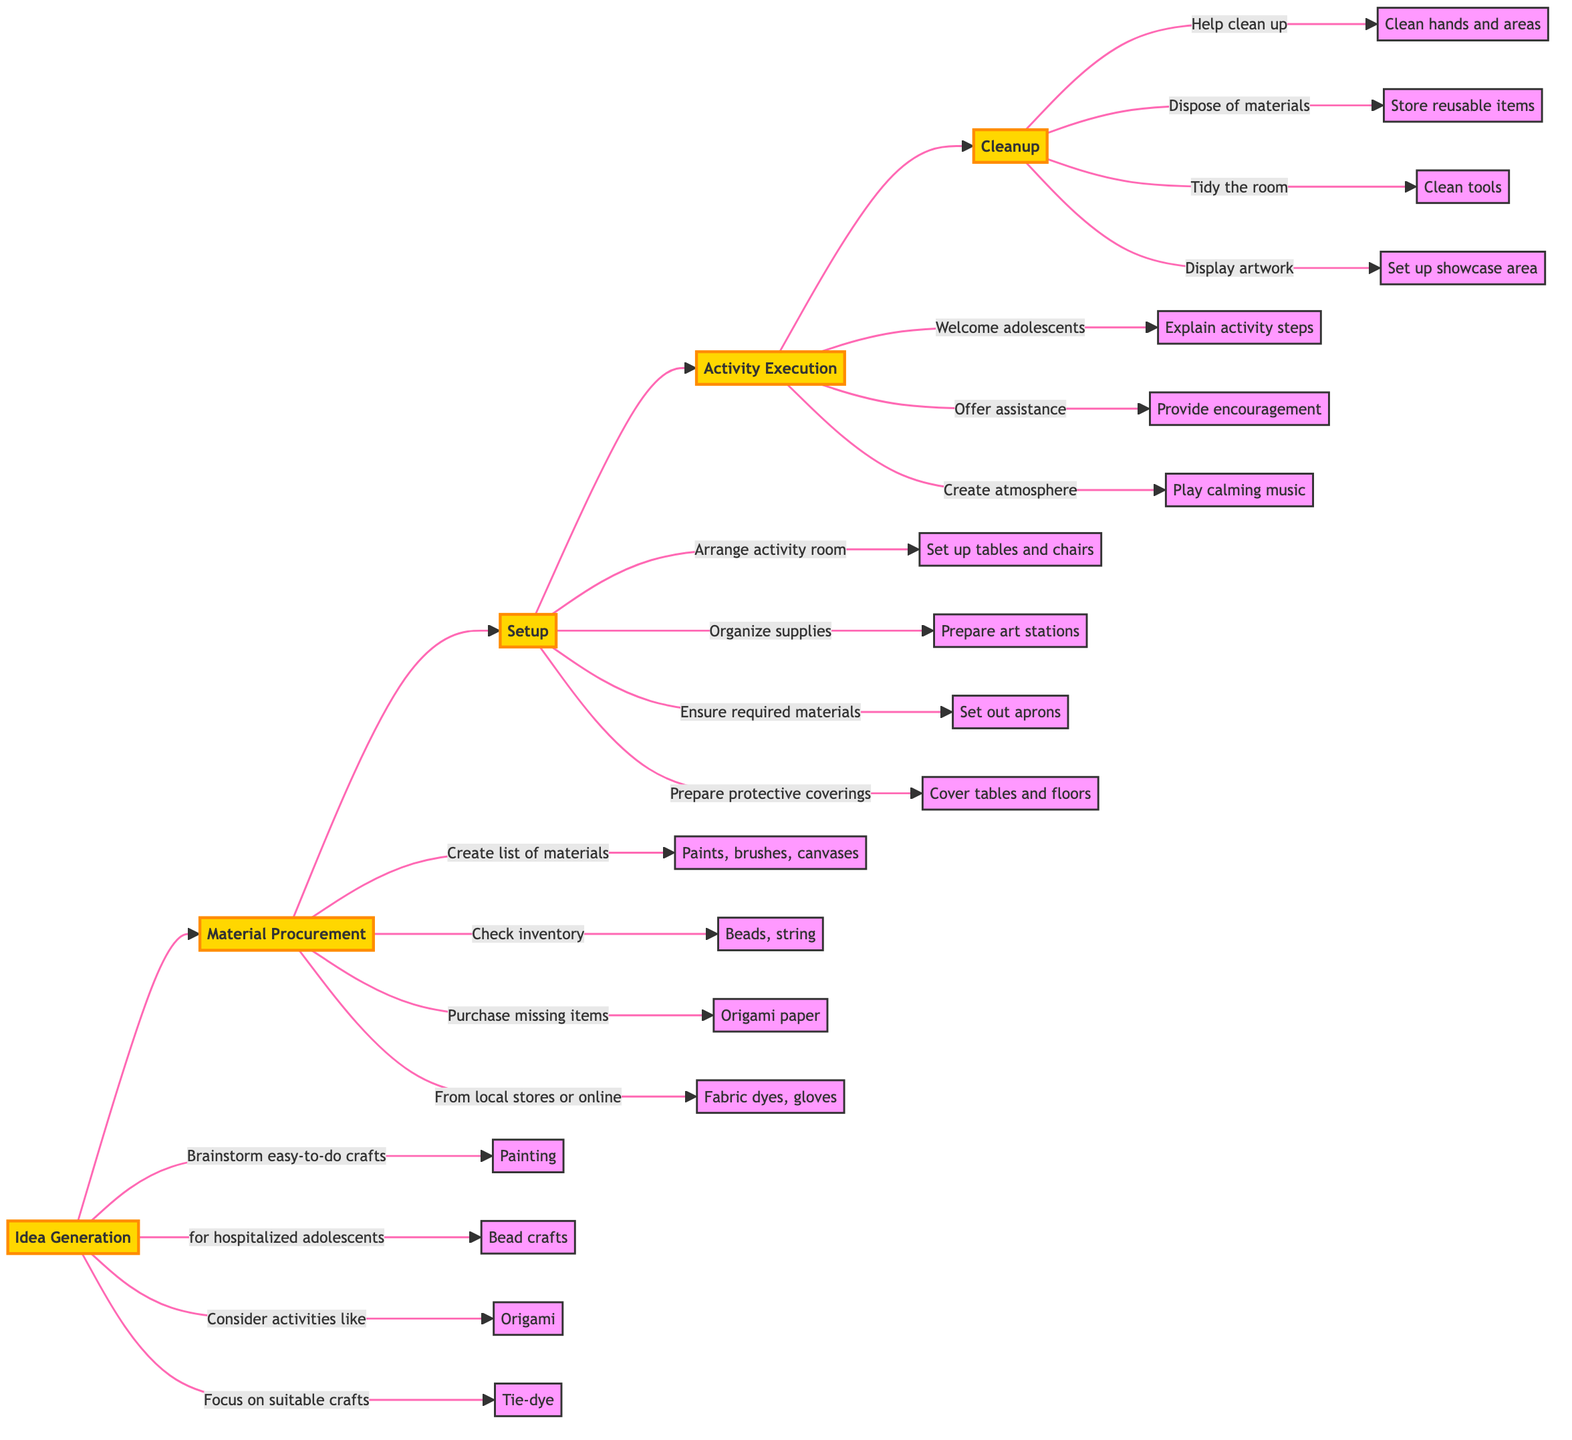What is the first step in the flowchart? The flowchart begins with the step labeled "Idea Generation." This is the first node in the horizontal arrangement of elements.
Answer: Idea Generation How many steps are there in total in the flowchart? The flowchart contains a total of five steps: Idea Generation, Material Procurement, Setup, Activity Execution, and Cleanup. By counting each distinct block, we reach this total.
Answer: 5 What are some activities listed under Idea Generation? Under the "Idea Generation" step, the activities mentioned include painting, bead crafts, origami, and tie-dye. These are specifically detailed as examples of suitable crafts.
Answer: Painting, bead crafts, origami, tie-dye What materials are included in Material Procurement? The "Material Procurement" step lists materials such as acrylic paints, brushes, canvases, beads, string, origami paper, fabric dyes, and gloves. These items are essential for the planned activities.
Answer: Acrylic paints, brushes, canvases, beads, string, origami paper, fabric dyes, gloves What is ensured during the Setup step? During the "Setup" step, it is ensured that each station has the required materials for the specific activity. This is important for organizing the workspace effectively and preparing for smooth execution.
Answer: Required materials for the specific activity What do participants do during Activity Execution? In the "Activity Execution" step, participants are welcomed, activity steps are explained clearly, and assistance is offered as they work on their projects. This ensures engagement and support throughout the activity.
Answer: Welcome participants and explain activity steps Which step includes cleaning hands and areas? The "Cleanup" step involves helping participants clean their hands and areas after the activities are finished. This is crucial for maintaining hygiene in the hospital setting.
Answer: Cleanup What is displayed after Cleanup? After the "Cleanup" step, the completed artworks are displayed in a designated area for everyone to enjoy. This final touch emphasizes appreciation for the creative efforts of the participants.
Answer: Completed artworks in a designated area What role does music play during Activity Execution? During the "Activity Execution" step, calming background music is played to create an enjoyable atmosphere for the participants while they engage in their art projects.
Answer: Calming background music 